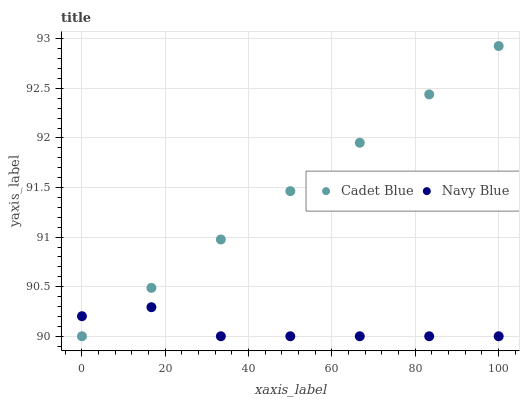Does Navy Blue have the minimum area under the curve?
Answer yes or no. Yes. Does Cadet Blue have the maximum area under the curve?
Answer yes or no. Yes. Does Cadet Blue have the minimum area under the curve?
Answer yes or no. No. Is Cadet Blue the smoothest?
Answer yes or no. Yes. Is Navy Blue the roughest?
Answer yes or no. Yes. Is Cadet Blue the roughest?
Answer yes or no. No. Does Navy Blue have the lowest value?
Answer yes or no. Yes. Does Cadet Blue have the highest value?
Answer yes or no. Yes. Does Cadet Blue intersect Navy Blue?
Answer yes or no. Yes. Is Cadet Blue less than Navy Blue?
Answer yes or no. No. Is Cadet Blue greater than Navy Blue?
Answer yes or no. No. 